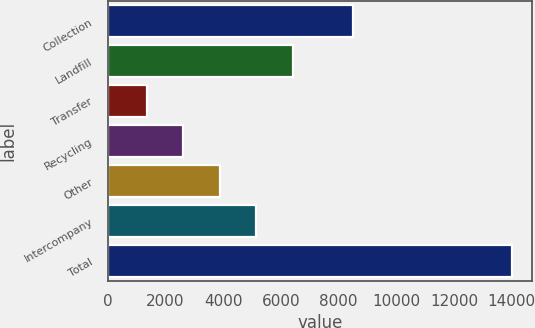Convert chart to OTSL. <chart><loc_0><loc_0><loc_500><loc_500><bar_chart><fcel>Collection<fcel>Landfill<fcel>Transfer<fcel>Recycling<fcel>Other<fcel>Intercompany<fcel>Total<nl><fcel>8507<fcel>6410.2<fcel>1353<fcel>2617.3<fcel>3881.6<fcel>5145.9<fcel>13996<nl></chart> 